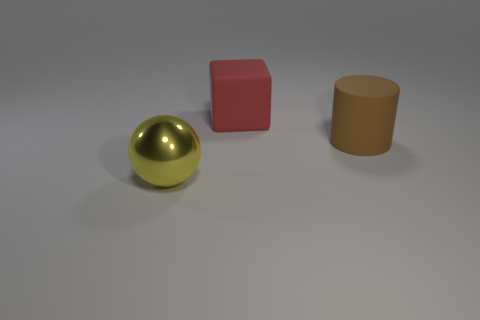Add 1 purple rubber blocks. How many objects exist? 4 Subtract 1 spheres. How many spheres are left? 0 Add 3 red objects. How many red objects are left? 4 Add 3 large brown matte things. How many large brown matte things exist? 4 Subtract 0 cyan spheres. How many objects are left? 3 Subtract all cubes. How many objects are left? 2 Subtract all yellow cylinders. Subtract all gray spheres. How many cylinders are left? 1 Subtract all red cubes. Subtract all big shiny balls. How many objects are left? 1 